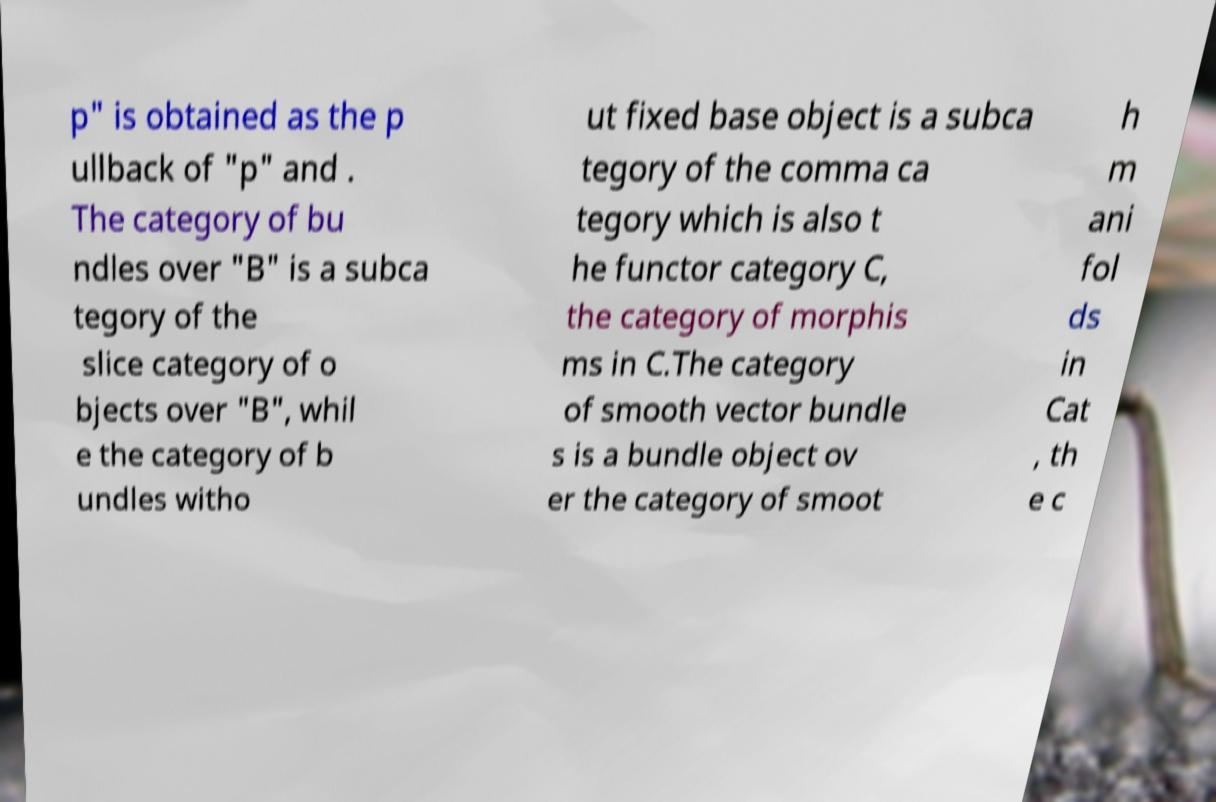Please identify and transcribe the text found in this image. p" is obtained as the p ullback of "p" and . The category of bu ndles over "B" is a subca tegory of the slice category of o bjects over "B", whil e the category of b undles witho ut fixed base object is a subca tegory of the comma ca tegory which is also t he functor category C, the category of morphis ms in C.The category of smooth vector bundle s is a bundle object ov er the category of smoot h m ani fol ds in Cat , th e c 